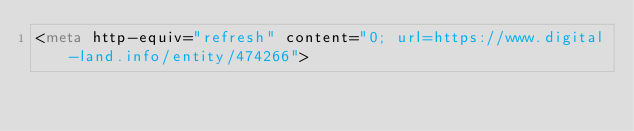Convert code to text. <code><loc_0><loc_0><loc_500><loc_500><_HTML_><meta http-equiv="refresh" content="0; url=https://www.digital-land.info/entity/474266"></code> 